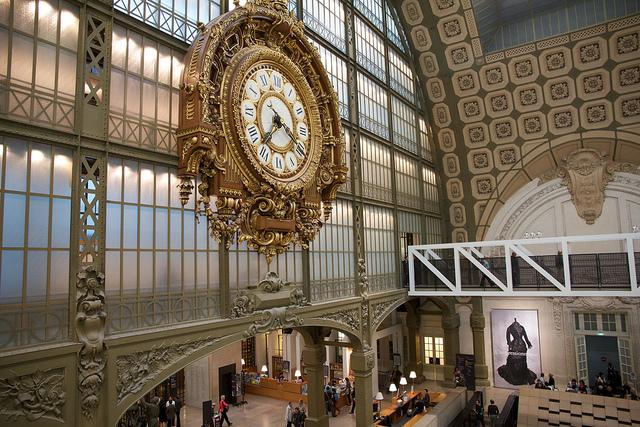What is on the advertisement overlooked by the gold clock? Please explain your reasoning. dress. A silhoutte of an outfit. 